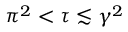Convert formula to latex. <formula><loc_0><loc_0><loc_500><loc_500>\pi ^ { 2 } < \tau \lesssim \gamma ^ { 2 }</formula> 